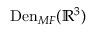<formula> <loc_0><loc_0><loc_500><loc_500>D e n _ { M F } ( \mathbb { R } ^ { 3 } )</formula> 